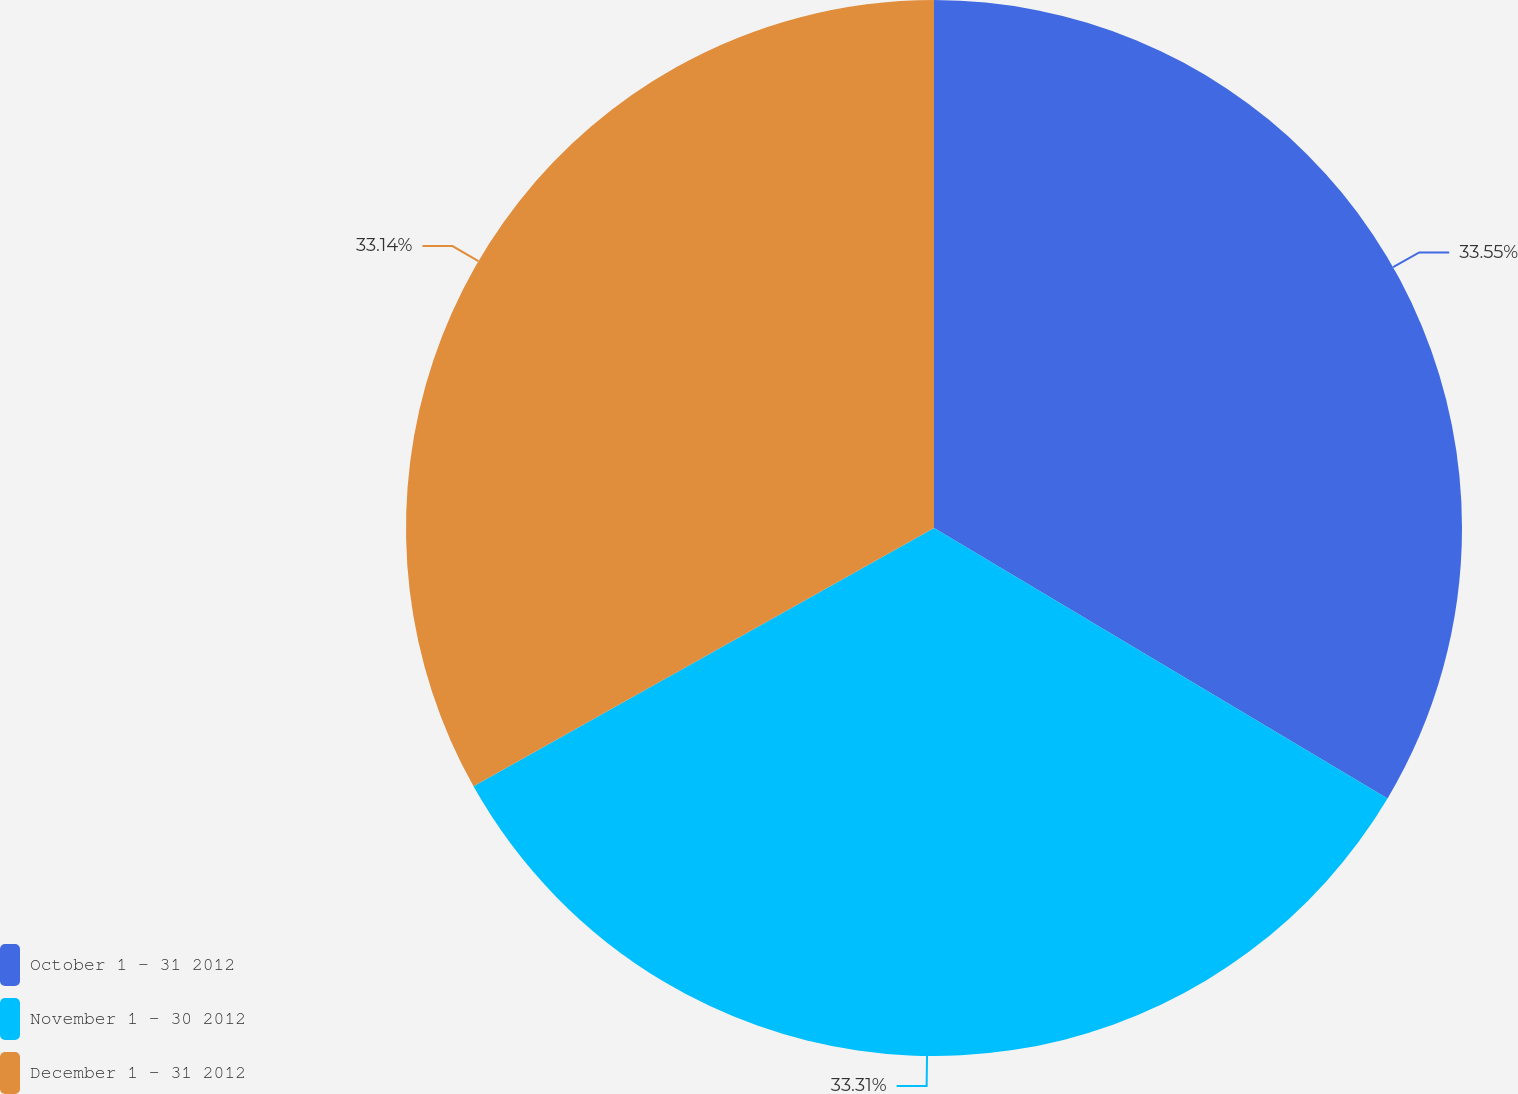<chart> <loc_0><loc_0><loc_500><loc_500><pie_chart><fcel>October 1 - 31 2012<fcel>November 1 - 30 2012<fcel>December 1 - 31 2012<nl><fcel>33.56%<fcel>33.31%<fcel>33.14%<nl></chart> 